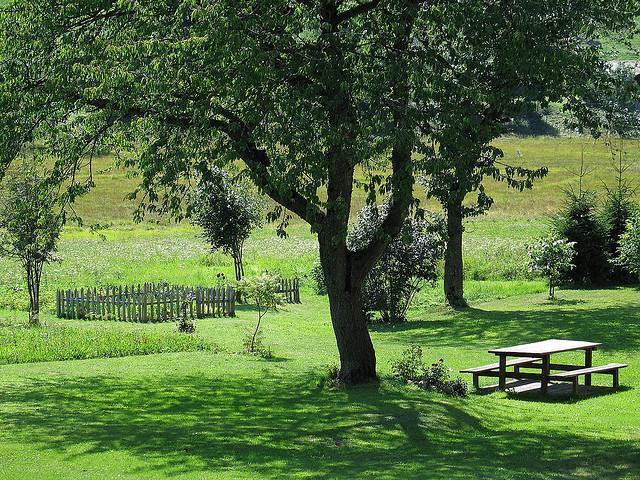How many people are sitting at the picnic table?
Give a very brief answer. 0. How many fences are there?
Give a very brief answer. 2. 